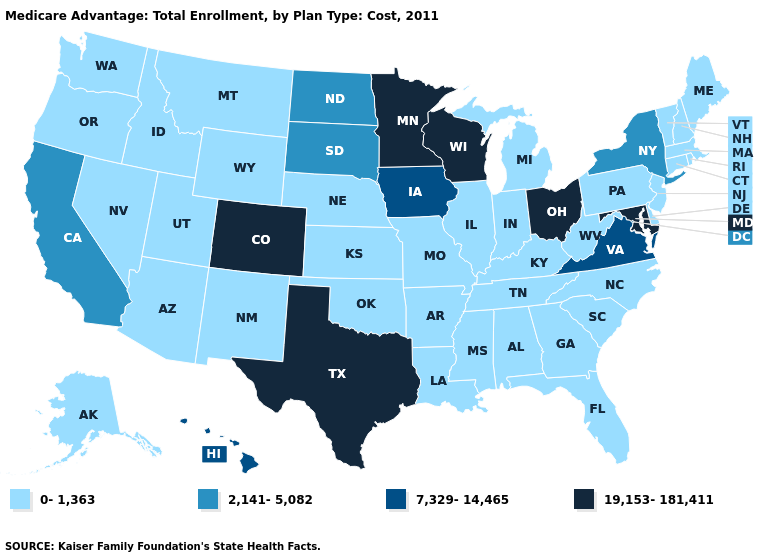Among the states that border Arkansas , which have the highest value?
Be succinct. Texas. Name the states that have a value in the range 7,329-14,465?
Write a very short answer. Hawaii, Iowa, Virginia. Name the states that have a value in the range 19,153-181,411?
Short answer required. Colorado, Maryland, Minnesota, Ohio, Texas, Wisconsin. What is the value of Missouri?
Concise answer only. 0-1,363. Does the map have missing data?
Quick response, please. No. Which states have the highest value in the USA?
Answer briefly. Colorado, Maryland, Minnesota, Ohio, Texas, Wisconsin. What is the value of Utah?
Give a very brief answer. 0-1,363. Does Nevada have the highest value in the West?
Answer briefly. No. What is the value of Arkansas?
Write a very short answer. 0-1,363. Among the states that border New Mexico , does Utah have the lowest value?
Give a very brief answer. Yes. What is the highest value in the Northeast ?
Concise answer only. 2,141-5,082. Does the first symbol in the legend represent the smallest category?
Give a very brief answer. Yes. Name the states that have a value in the range 19,153-181,411?
Short answer required. Colorado, Maryland, Minnesota, Ohio, Texas, Wisconsin. Name the states that have a value in the range 0-1,363?
Short answer required. Alaska, Alabama, Arkansas, Arizona, Connecticut, Delaware, Florida, Georgia, Idaho, Illinois, Indiana, Kansas, Kentucky, Louisiana, Massachusetts, Maine, Michigan, Missouri, Mississippi, Montana, North Carolina, Nebraska, New Hampshire, New Jersey, New Mexico, Nevada, Oklahoma, Oregon, Pennsylvania, Rhode Island, South Carolina, Tennessee, Utah, Vermont, Washington, West Virginia, Wyoming. Does New York have the highest value in the USA?
Short answer required. No. 